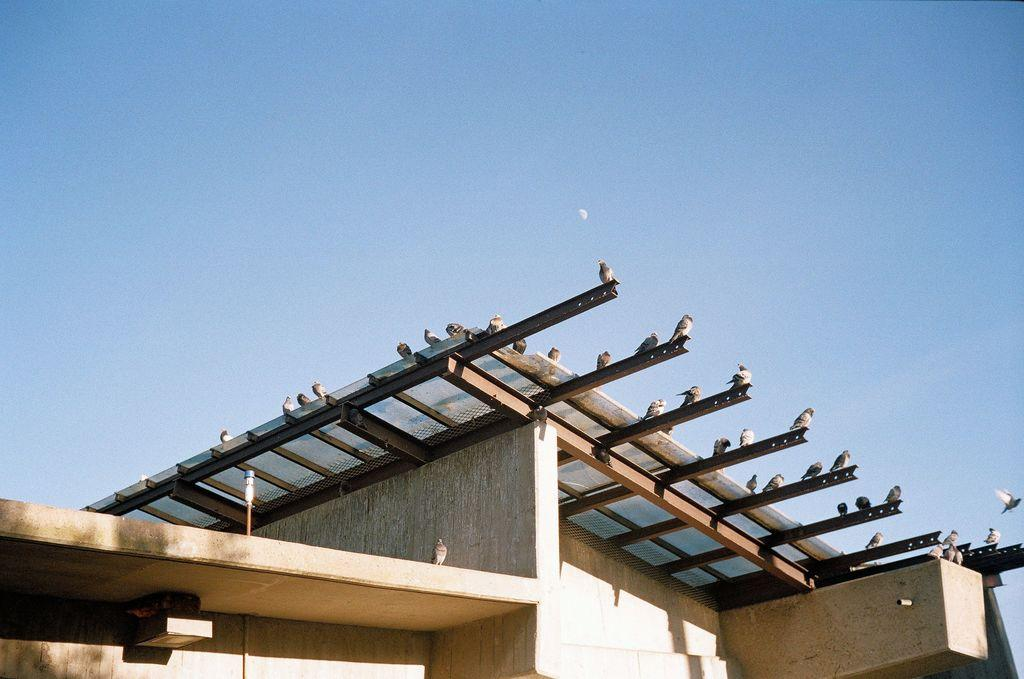What type of structure is visible in the image? There is a building in the image. What animals can be seen near the building? Birds are standing on metal rods near the building. What is visible at the top of the image? The sky is visible at the top of the image. What type of vein is visible in the image? There is no vein present in the image. What did the birds have for breakfast in the image? There is no information about the birds' breakfast in the image. 